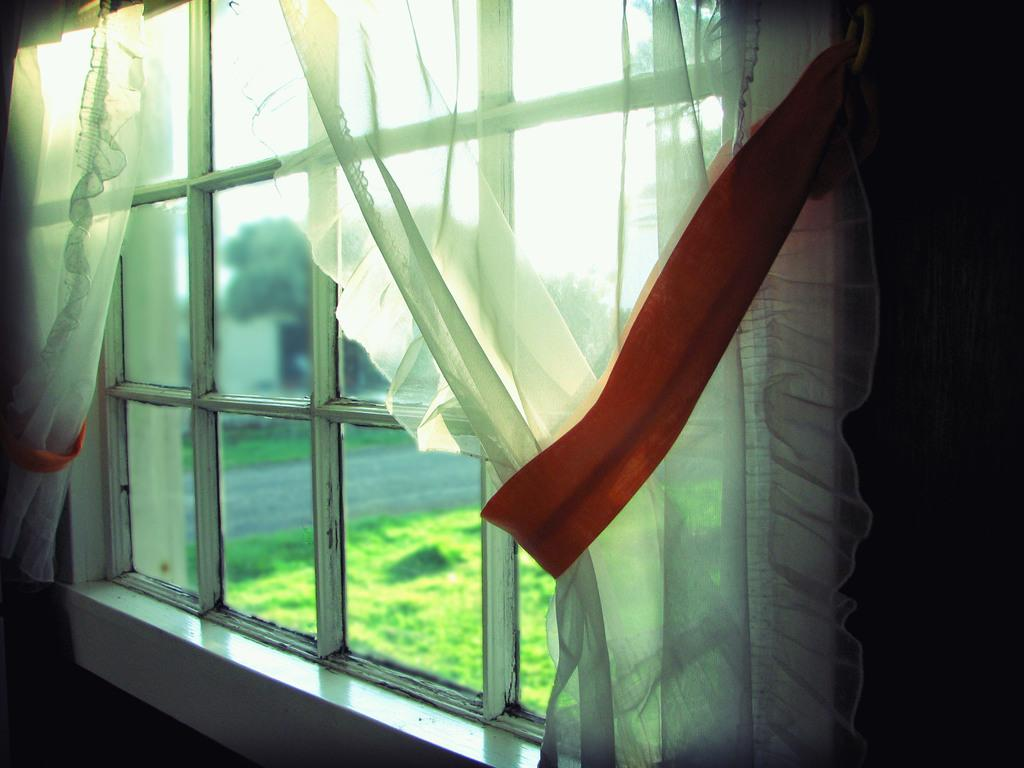What is present in the image that allows light to enter the room? There is a window in the image. What is used to cover or decorate the window? There are curtains associated with the window. What type of natural environment can be seen in the background of the image? There are trees, grass, and a wall visible in the background of the image. What part of the sky is visible in the image? The sky is visible in the background of the image. What type of sticks are being used to hold up the hope in the image? There is no mention of hope or sticks in the image; it only features a window, curtains, and a natural background. 